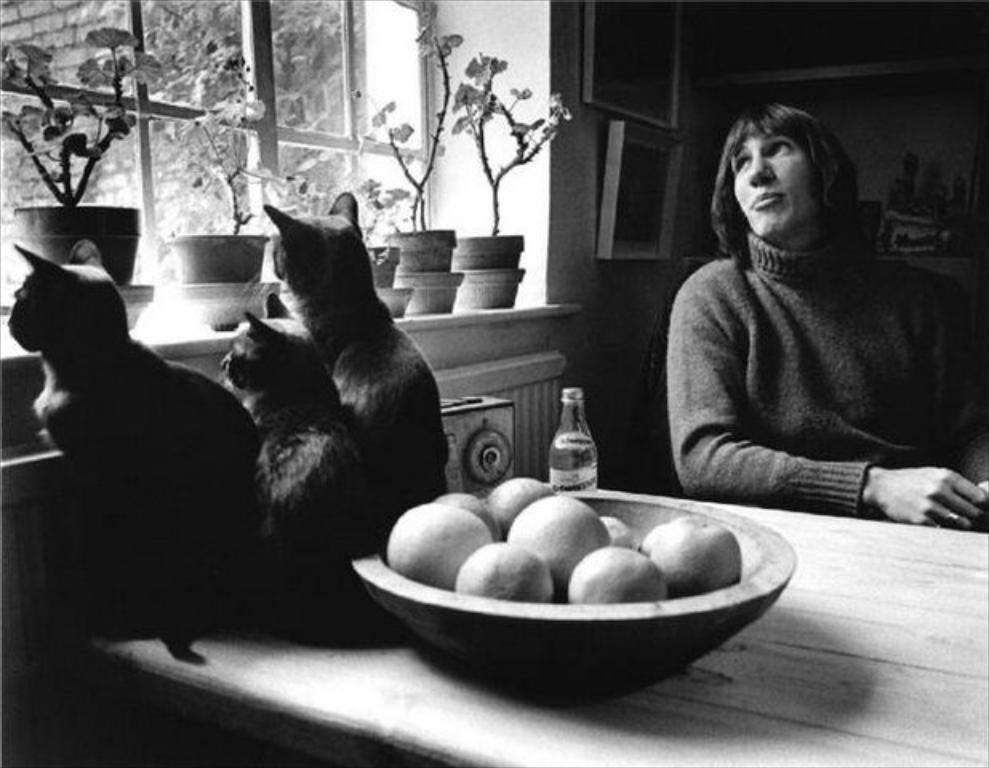What is the woman in the image doing? The woman is sitting on a chair in the image. What is in front of the woman? There is a table in front of the woman. What can be found on the table? There are fruits and cats on the table. Are there any plants visible in the image? Yes, there are flower pots in the image. What is the source of natural light in the image? There is a window in the image. What type of circle can be seen on the woman's shirt in the image? There is no circle visible on the woman's shirt in the image. What riddle is the woman trying to solve in the image? There is no riddle present in the image; the woman is simply sitting on a chair. 